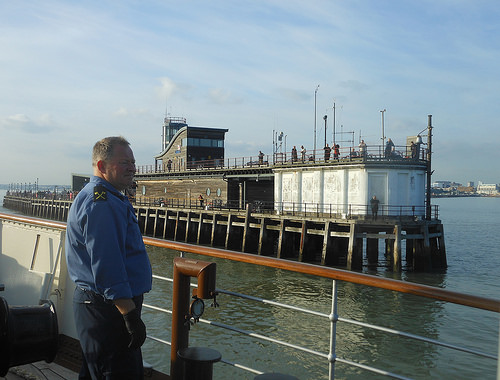<image>
Is there a man behind the fence? Yes. From this viewpoint, the man is positioned behind the fence, with the fence partially or fully occluding the man. 